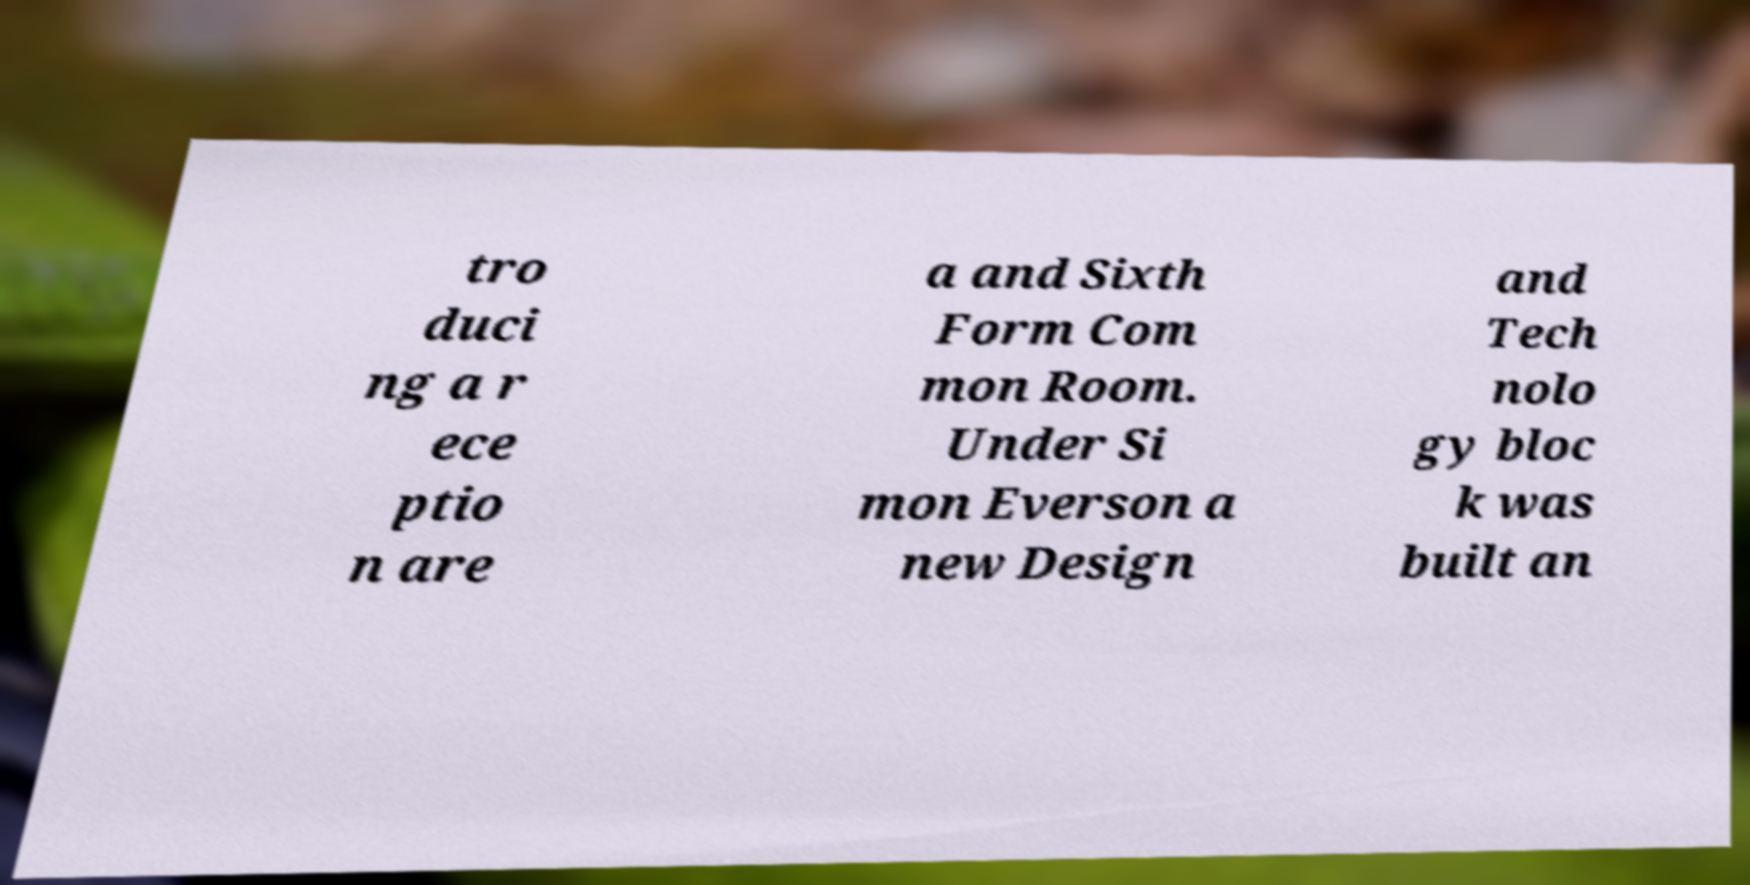Please identify and transcribe the text found in this image. tro duci ng a r ece ptio n are a and Sixth Form Com mon Room. Under Si mon Everson a new Design and Tech nolo gy bloc k was built an 